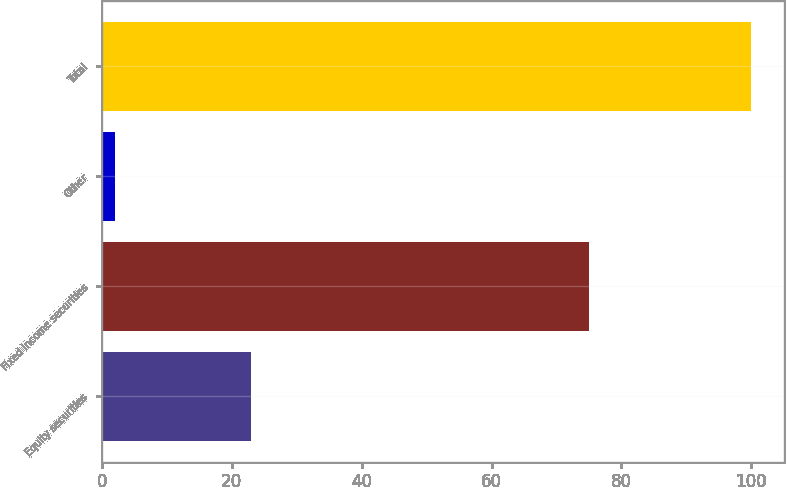<chart> <loc_0><loc_0><loc_500><loc_500><bar_chart><fcel>Equity securities<fcel>Fixed income securities<fcel>Other<fcel>Total<nl><fcel>23<fcel>75<fcel>2<fcel>100<nl></chart> 